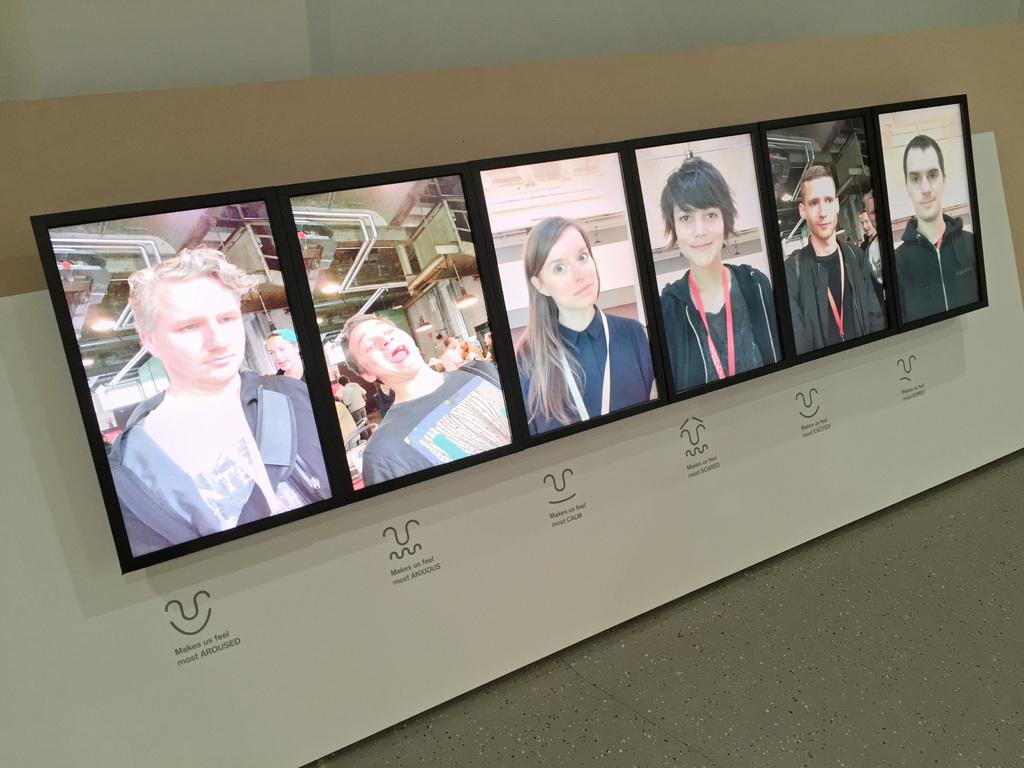What is hanging from the banner in the image? There are photo frames attached to a banner in the image. What can be seen behind the banner in the image? There is a wall in the background of the image. What is the surface beneath the banner in the image? There is a floor at the bottom of the image. What route does the banner take to reach the wall in the image? The banner does not take a route to reach the wall; it is already attached to the wall in the image. 